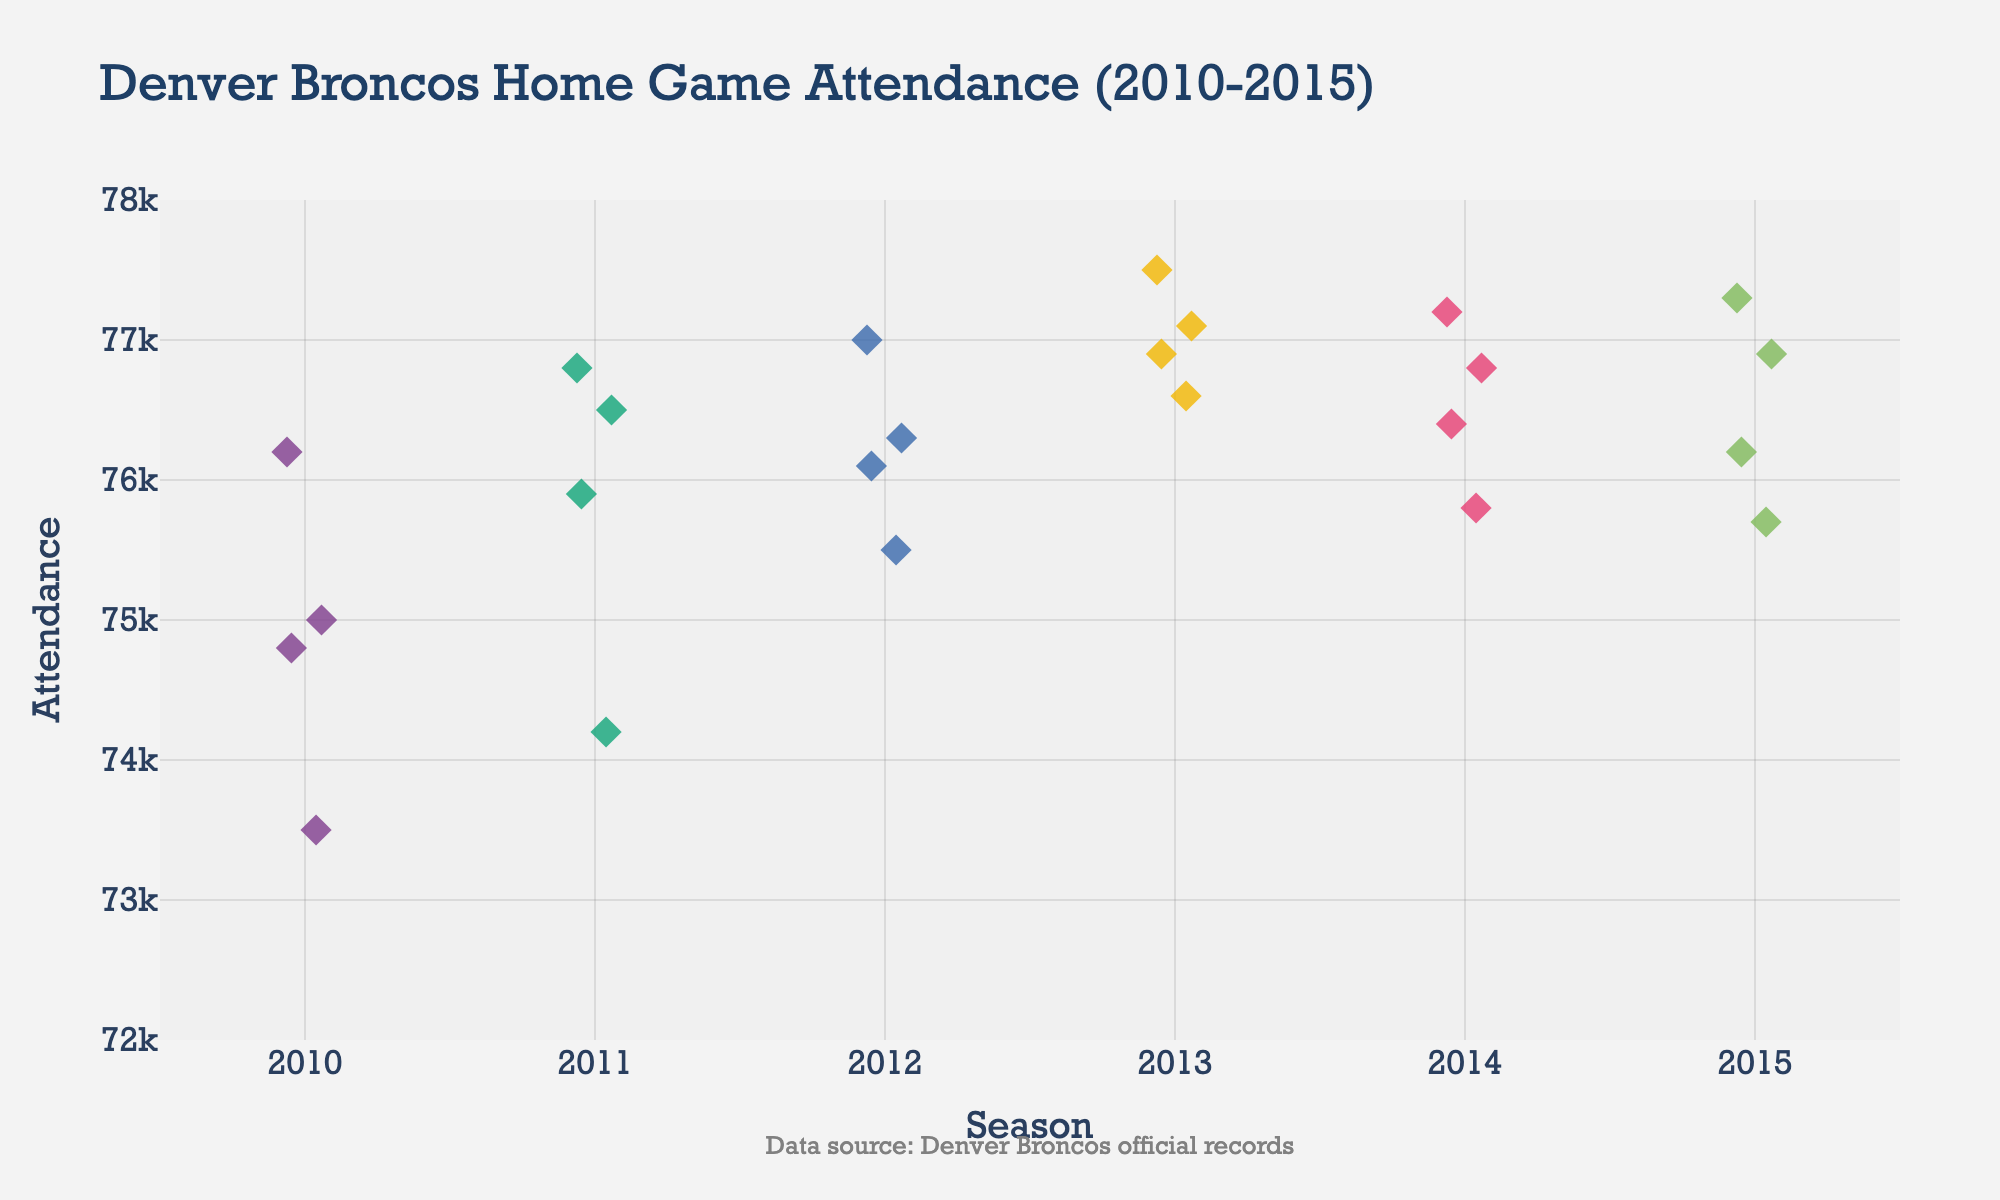How many seasons are represented in the plot? There are six distinct seasons shown in the plot from 2010 to 2015. Each season is marked along the x-axis.
Answer: 6 What is the range of attendance in the 2010 season? The lowest attendance in 2010 is 73,500 and the highest is 76,200. The range is the difference between these values, which is 76,200 - 73,500 = 2,700.
Answer: 2,700 Which season has the highest average attendance? To find the average attendance for each season, sum the attendance values for each season and divide by the number of games. By comparing these averages, the 2013 season has the highest average attendance.
Answer: 2013 What is the median attendance figure for the 2012 season? The attendance values for 2012 are 76100, 77000, 75500, and 76300. To find the median, arrange the values in order: 75500, 76100, 76300, 77000. The median is the average of the two middle numbers: (76100 + 76300) / 2 = 76200.
Answer: 76200 Are there more data points above or below the attendance threshold of 76,000 in the 2013 season? The 2013 season has attendance values 76900, 77100, 76600, and 77500. Above 76,000 are 76900, 77100, and 77500 (3 points). Below 76,000 is 76600 (1 point). There are more points above 76,000.
Answer: Above Which season shows the least variation in attendance figures? Variance is measured by observing the spread of data points. Visually, 2011 has the least spread with attendances ranging closely around 75,900 to 76,800.
Answer: 2011 How many attendances fall within the range of 75,000 to 76,000 in the entire plot? Count the number of data points that lie between 75,000 and 76,000 by inspecting the hover tooltips or visually estimating. There are several points in multiple seasons, specifically 2010, 2011, and 2012.
Answer: Nine What annotation is included in the plot? Observing the lower part of the plot, there's a text annotation indicating the data source: "Data source: Denver Broncos official records".
Answer: Data source: Denver Broncos official records Does the 2015 season have any attendances above 77,000? The 2015 season includes attendances like 76200, 76900, 75700, and 77300. None of these values exceed 77,000.
Answer: No What is the overall highest attendance figure in the whole plot? Scanning through the y-axis and the highest data points in each cluster, the peak attendance is 77,500 recorded in the 2013 season.
Answer: 77,500 